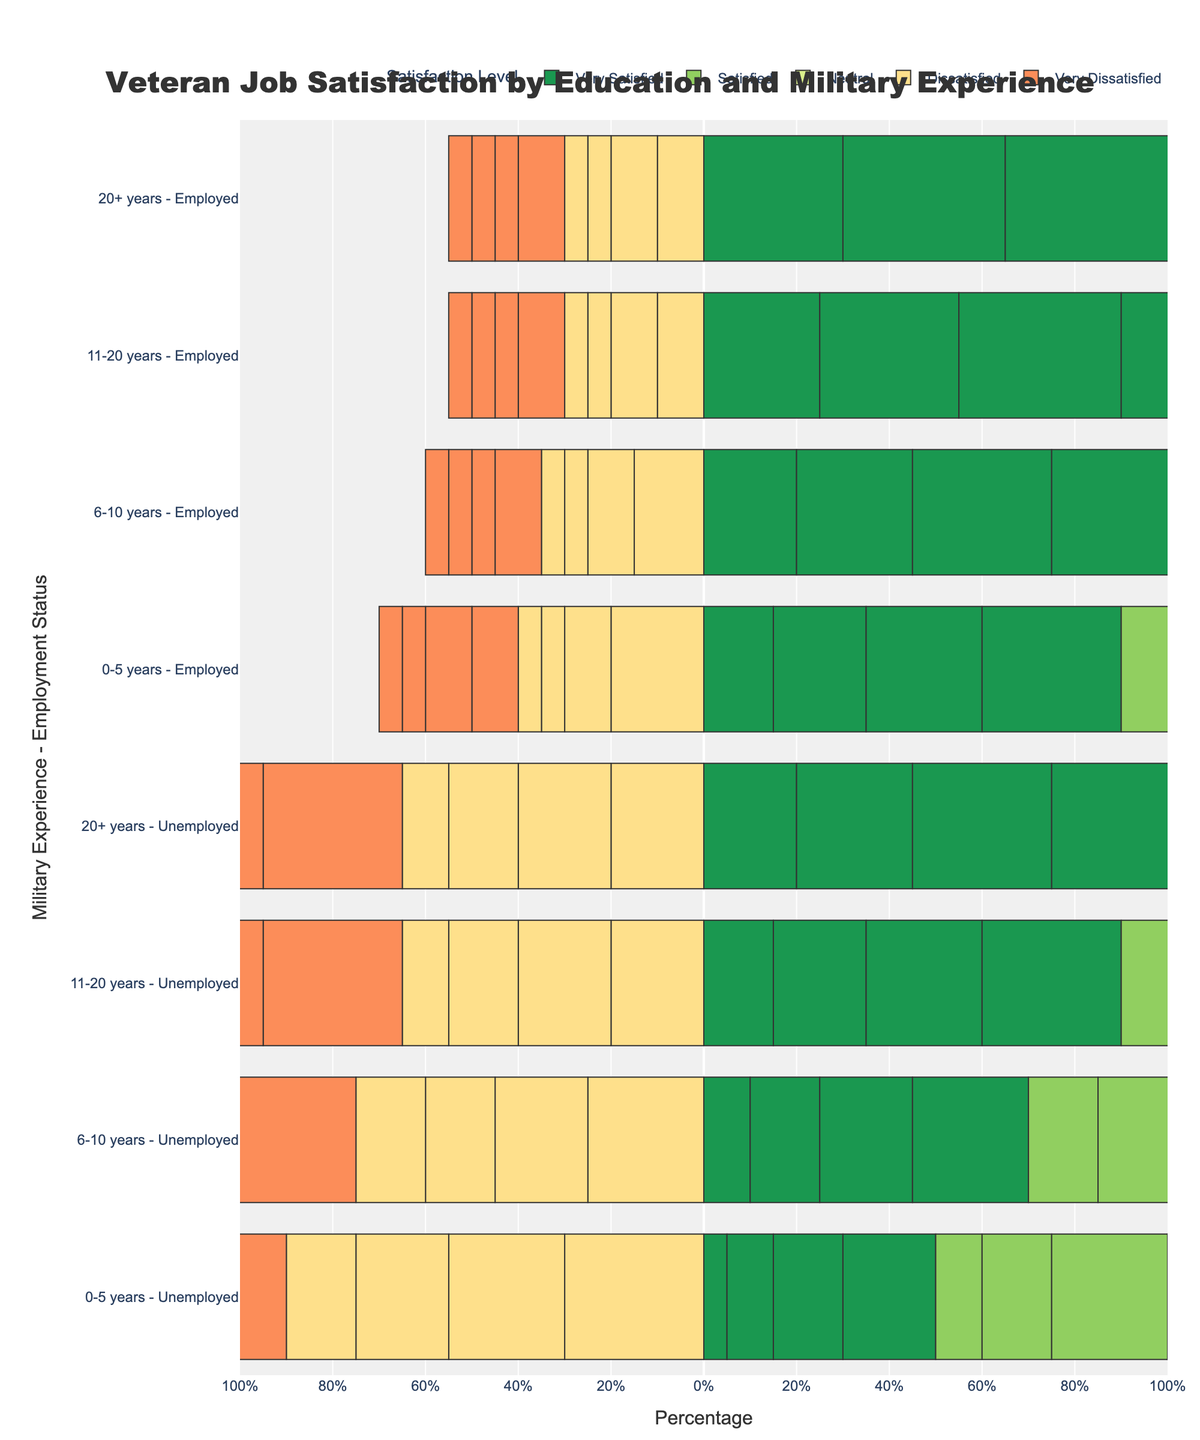Which education level shows the highest percentage of "Very Satisfied" employees with 20+ years of military experience? Look for the bar representing "Very Satisfied" within the 20+ years military experience and employed sections for each education level. Compare the lengths of these bars.
Answer: Master's Degree Do unemployed veterans with a Bachelor's Degree and 0-5 years of military experience have a higher percentage of "Very Dissatisfied" responses compared to those with an Associate Degree in the same category? Compare the lengths of the "Very Dissatisfied" bars for unemployed veterans with a Bachelor's Degree and an Associate Degree in the 0-5 years military experience category.
Answer: Yes Which satisfaction level has the largest percentage for employees with a High School Diploma and 6-10 years of military experience? Look at the lengths of all satisfaction level bars for employed veterans with a High School Diploma and 6-10 years of military experience. The longest bar indicates the largest percentage.
Answer: Satisfied For veterans with more than 20 years of military experience and an Associate Degree, what is the difference in the percentage of "Neutral" responses between employed and unemployed individuals? Subtract the percentage of "Neutral" for unemployed veterans from the percentage of "Neutral" for employed veterans within the more than 20 years of experience category and holding an Associate Degree.
Answer: 0% Is the sum of the percentages of "Very Satisfied" and "Satisfied" higher for employed or unemployed veterans with a Master's Degree and 11-20 years of experience? Add the percentages of "Very Satisfied" and "Satisfied" for both employed and unemployed veterans within the Master's Degree and 11-20 years of experience category and compare the results.
Answer: Employed For veterans with a Bachelor's Degree and 6-10 years of military experience, which satisfaction level has the lowest percentage among employed individuals? Identify the shortest bar within the employed veterans holding a Bachelor's Degree and having 6-10 years of military experience. This bar represents the lowest percentage satisfaction level.
Answer: Very Dissatisfied Among veterans with an Associate Degree and 0-5 years of military experience, do employed or unemployed individuals show a higher percentage of "Neutral" responses? Compare the length of "Neutral" bars for employed and unemployed veterans within the Associate Degree and 0-5 years military experience category.
Answer: Unemployed Do veterans with 0-5 years of military experience and a Master's Degree show a higher percentage of "Satisfied" or "Very Satisfied" responses when employed? Compare the lengths of "Satisfied" and "Very Satisfied" bars for employed veterans with a Master's Degree and 0-5 years of military experience.
Answer: Satisfied 